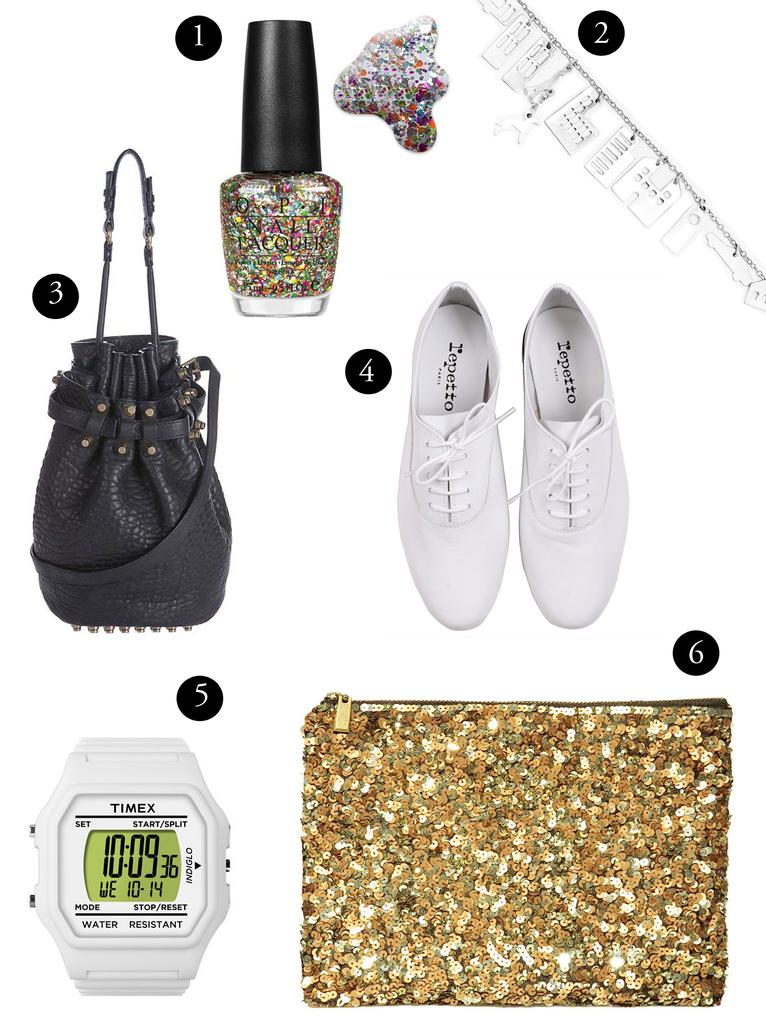<image>
Describe the image concisely. A pair of shoes is labeled number 4, while a watch is labeled number 5. 